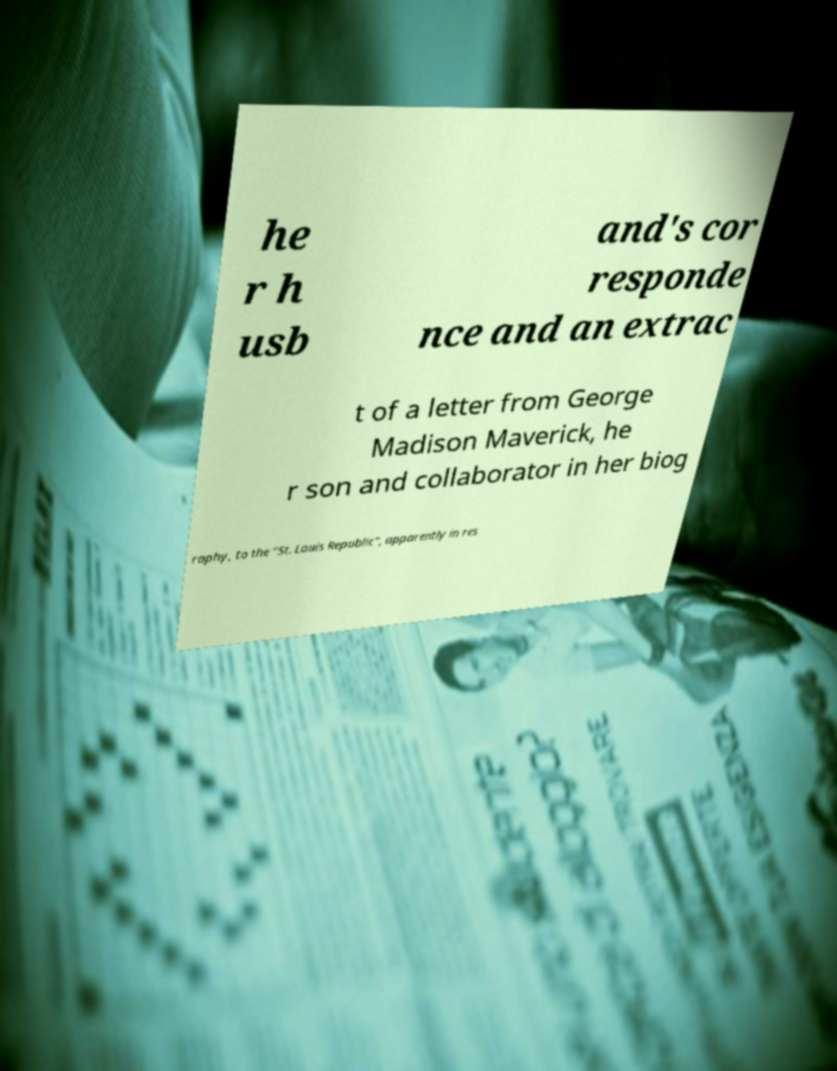What messages or text are displayed in this image? I need them in a readable, typed format. he r h usb and's cor responde nce and an extrac t of a letter from George Madison Maverick, he r son and collaborator in her biog raphy, to the "St. Louis Republic", apparently in res 